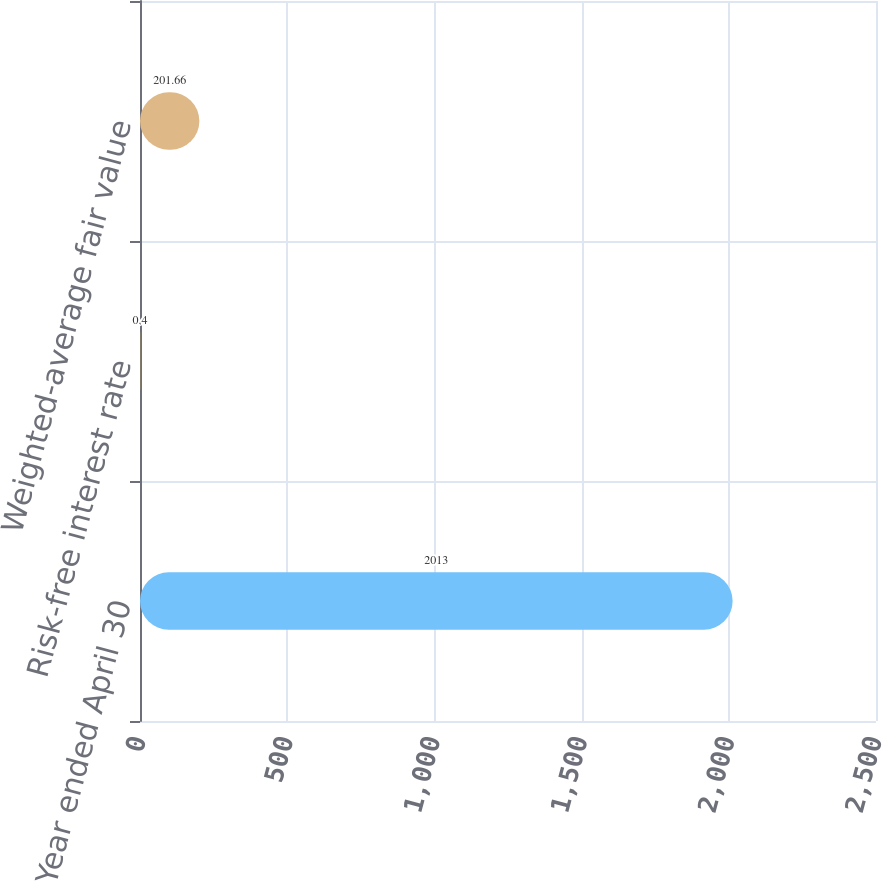<chart> <loc_0><loc_0><loc_500><loc_500><bar_chart><fcel>Year ended April 30<fcel>Risk-free interest rate<fcel>Weighted-average fair value<nl><fcel>2013<fcel>0.4<fcel>201.66<nl></chart> 